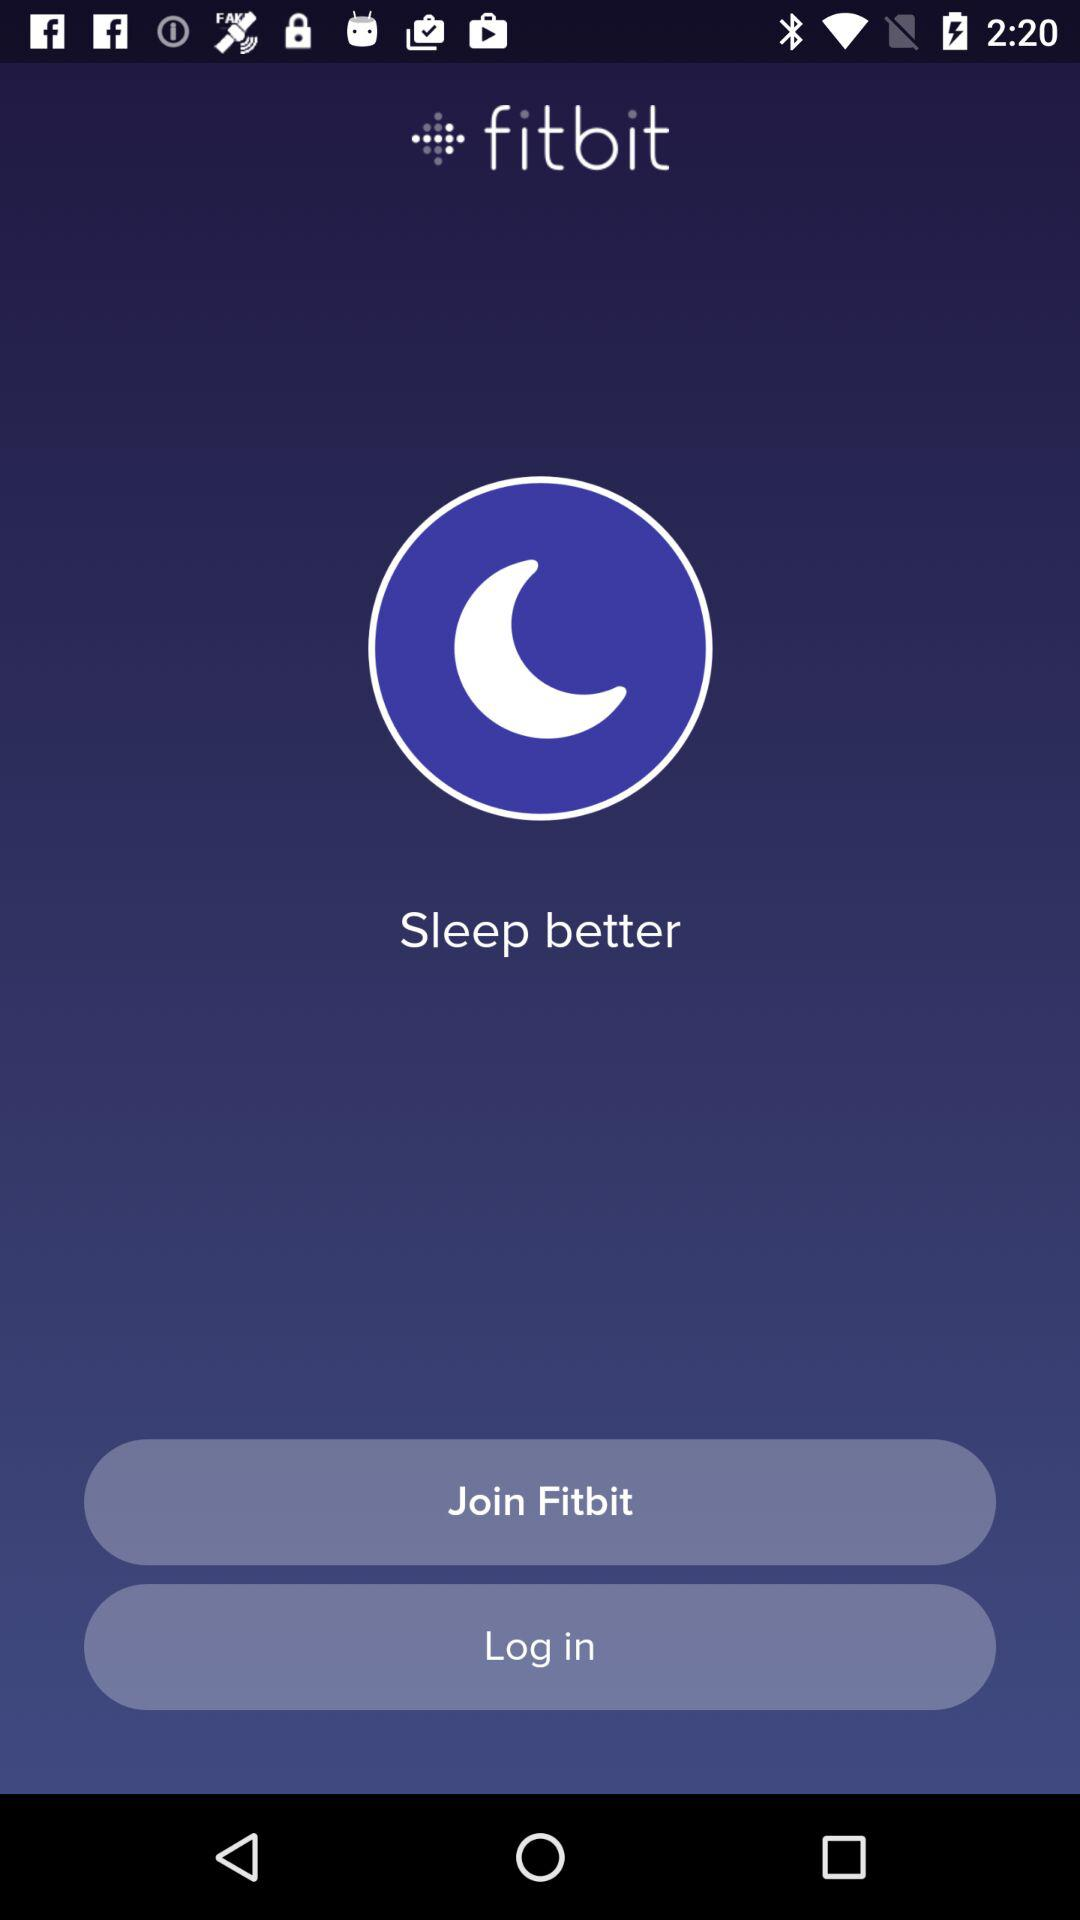What is the app name? The app name is "fitbit". 